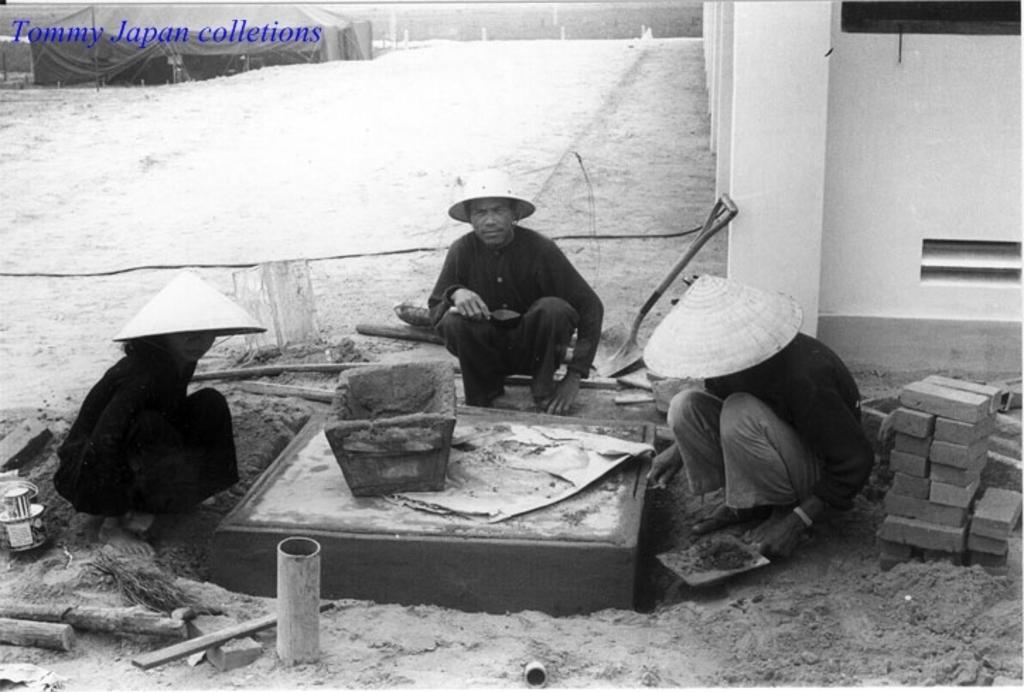Could you give a brief overview of what you see in this image? This is black and white image. In this image we can see there are people. There is a tent and a wall. In the top left corner there is a watermark.  